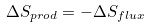<formula> <loc_0><loc_0><loc_500><loc_500>\Delta S _ { p r o d } = - \Delta S _ { f l u x }</formula> 